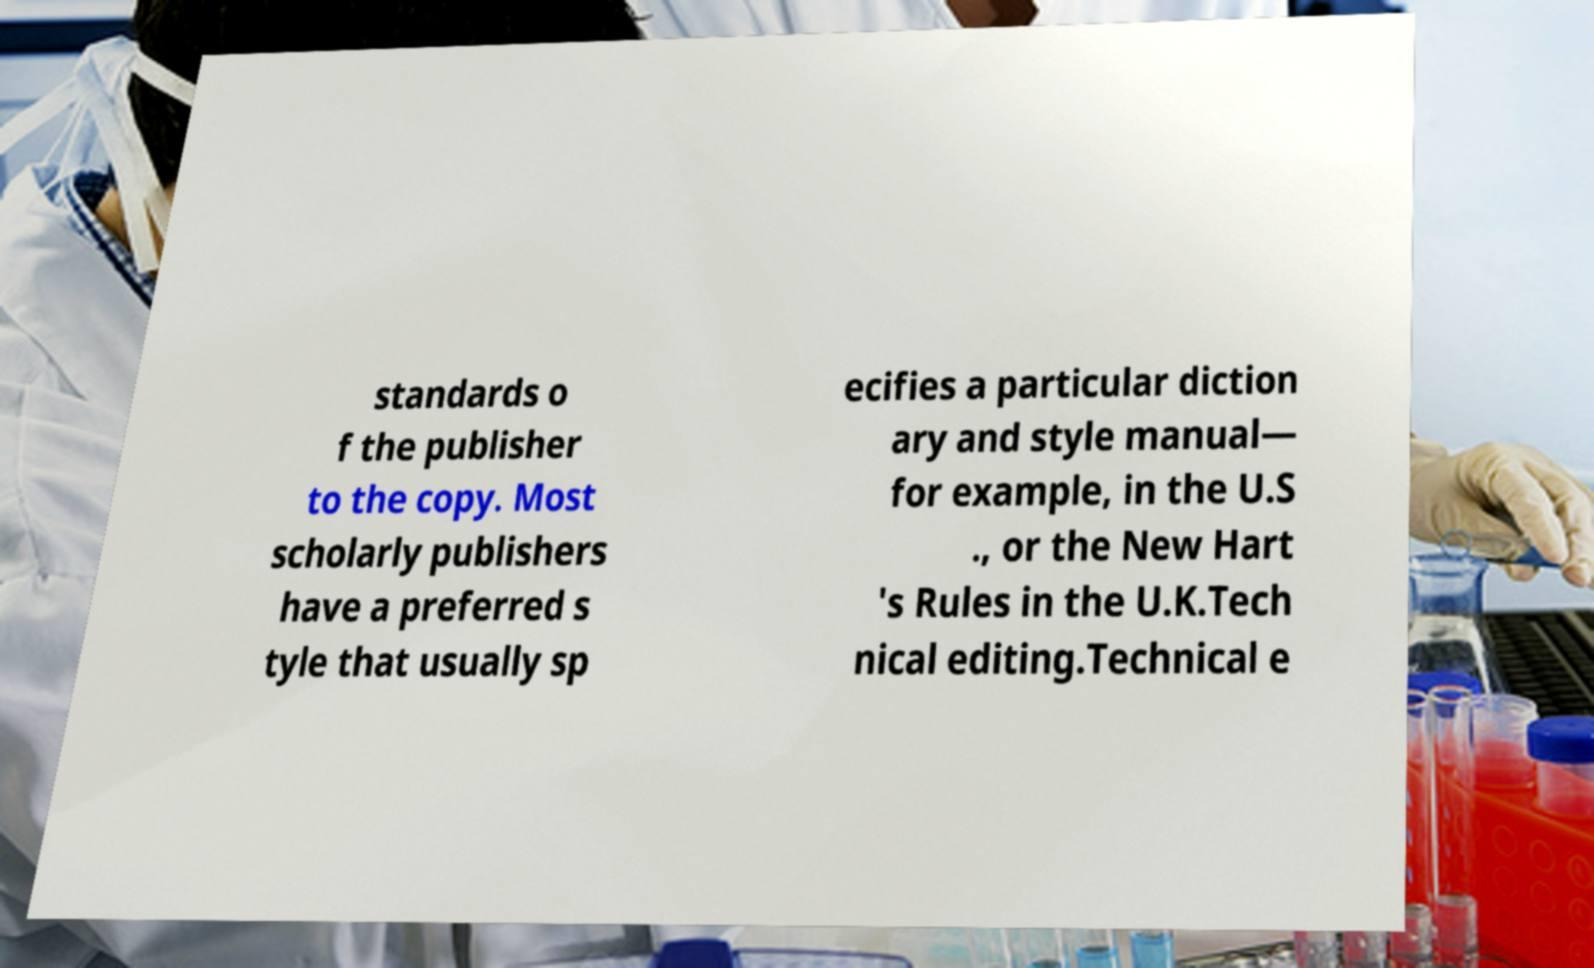I need the written content from this picture converted into text. Can you do that? standards o f the publisher to the copy. Most scholarly publishers have a preferred s tyle that usually sp ecifies a particular diction ary and style manual— for example, in the U.S ., or the New Hart 's Rules in the U.K.Tech nical editing.Technical e 